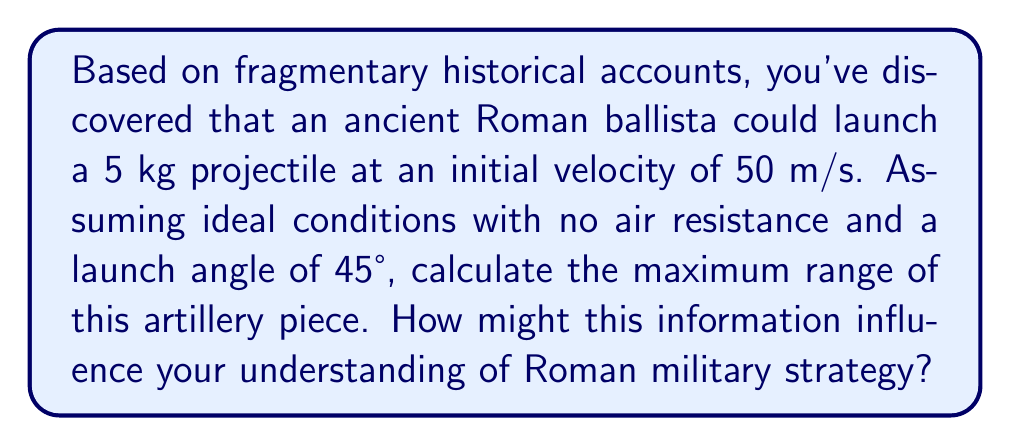Teach me how to tackle this problem. To solve this problem, we'll use the equations of motion for projectile motion. As a history professor specializing in military strategy, understanding the capabilities of ancient artillery can provide insights into tactical decisions and battlefield layouts.

Step 1: Identify the relevant equation for the range of a projectile.
The range (R) of a projectile launched at an angle θ with initial velocity v₀ is given by:

$$ R = \frac{v_0^2 \sin(2\theta)}{g} $$

Where g is the acceleration due to gravity (9.8 m/s²).

Step 2: Input the known values.
v₀ = 50 m/s
θ = 45°
g = 9.8 m/s²

Step 3: Calculate sin(2θ).
sin(2 * 45°) = sin(90°) = 1

Step 4: Substitute the values into the equation.

$$ R = \frac{(50 \text{ m/s})^2 \cdot 1}{9.8 \text{ m/s}^2} $$

Step 5: Solve for R.

$$ R = \frac{2500 \text{ m}^2/\text{s}^2}{9.8 \text{ m/s}^2} \approx 255.1 \text{ m} $$

The maximum range of the Roman ballista under these conditions is approximately 255.1 meters.

This information can influence our understanding of Roman military strategy in several ways:
1. It helps determine the effective combat range of Roman artillery units.
2. It provides insights into the positioning of artillery in battle formations.
3. It aids in understanding the role of artillery in siege warfare and fortification design.
4. It allows for comparison with other ancient artillery systems, potentially revealing technological advantages or disadvantages.
Answer: 255.1 meters 